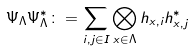<formula> <loc_0><loc_0><loc_500><loc_500>\Psi _ { \Lambda } \Psi _ { \Lambda } ^ { * } \colon = \sum _ { i , j \in I } \bigotimes _ { x \in \Lambda } h _ { x , i } h _ { x , j } ^ { * }</formula> 